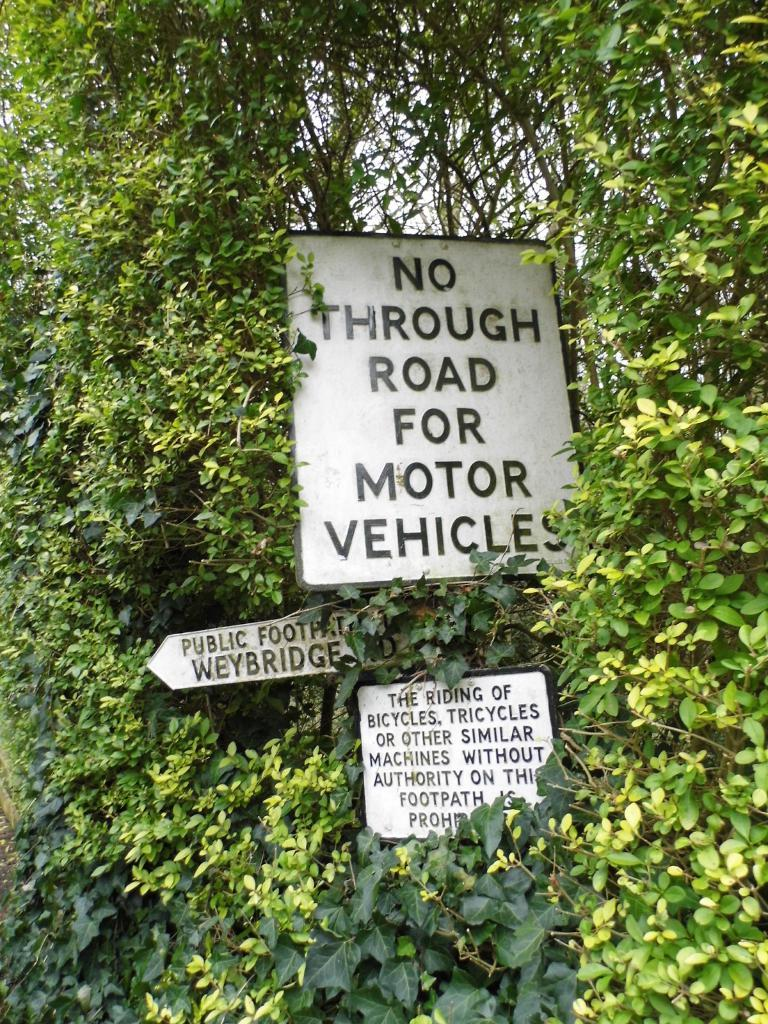What objects are present in the image? There are three white color boards in the image. What can be seen surrounding the color boards? There are trees around the boards. What is visible in the background of the image? The sky is visible in the background of the image. How many babies are involved in the humorous fight depicted in the image? There is no humorous fight involving babies depicted in the image; it features three white color boards surrounded by trees with the sky visible in the background. 